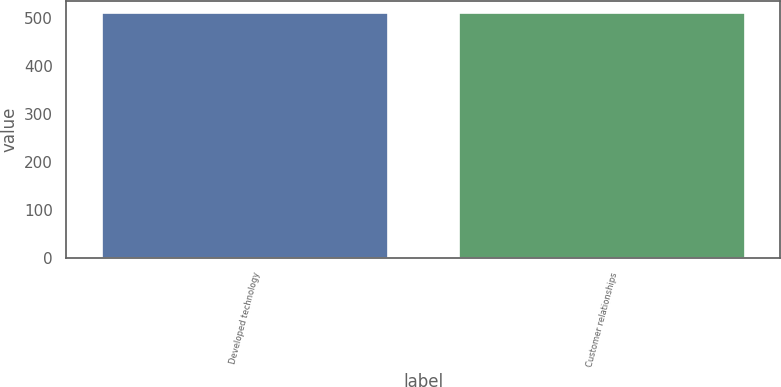<chart> <loc_0><loc_0><loc_500><loc_500><bar_chart><fcel>Developed technology<fcel>Customer relationships<nl><fcel>510<fcel>510.1<nl></chart> 